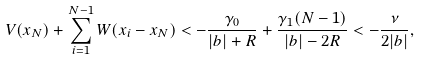Convert formula to latex. <formula><loc_0><loc_0><loc_500><loc_500>V ( x _ { N } ) + \sum _ { i = 1 } ^ { N - 1 } W ( x _ { i } - x _ { N } ) < - \frac { \gamma _ { 0 } } { | b | + R } + \frac { \gamma _ { 1 } ( N - 1 ) } { | b | - 2 R } < - \frac { \nu } { 2 | b | } ,</formula> 